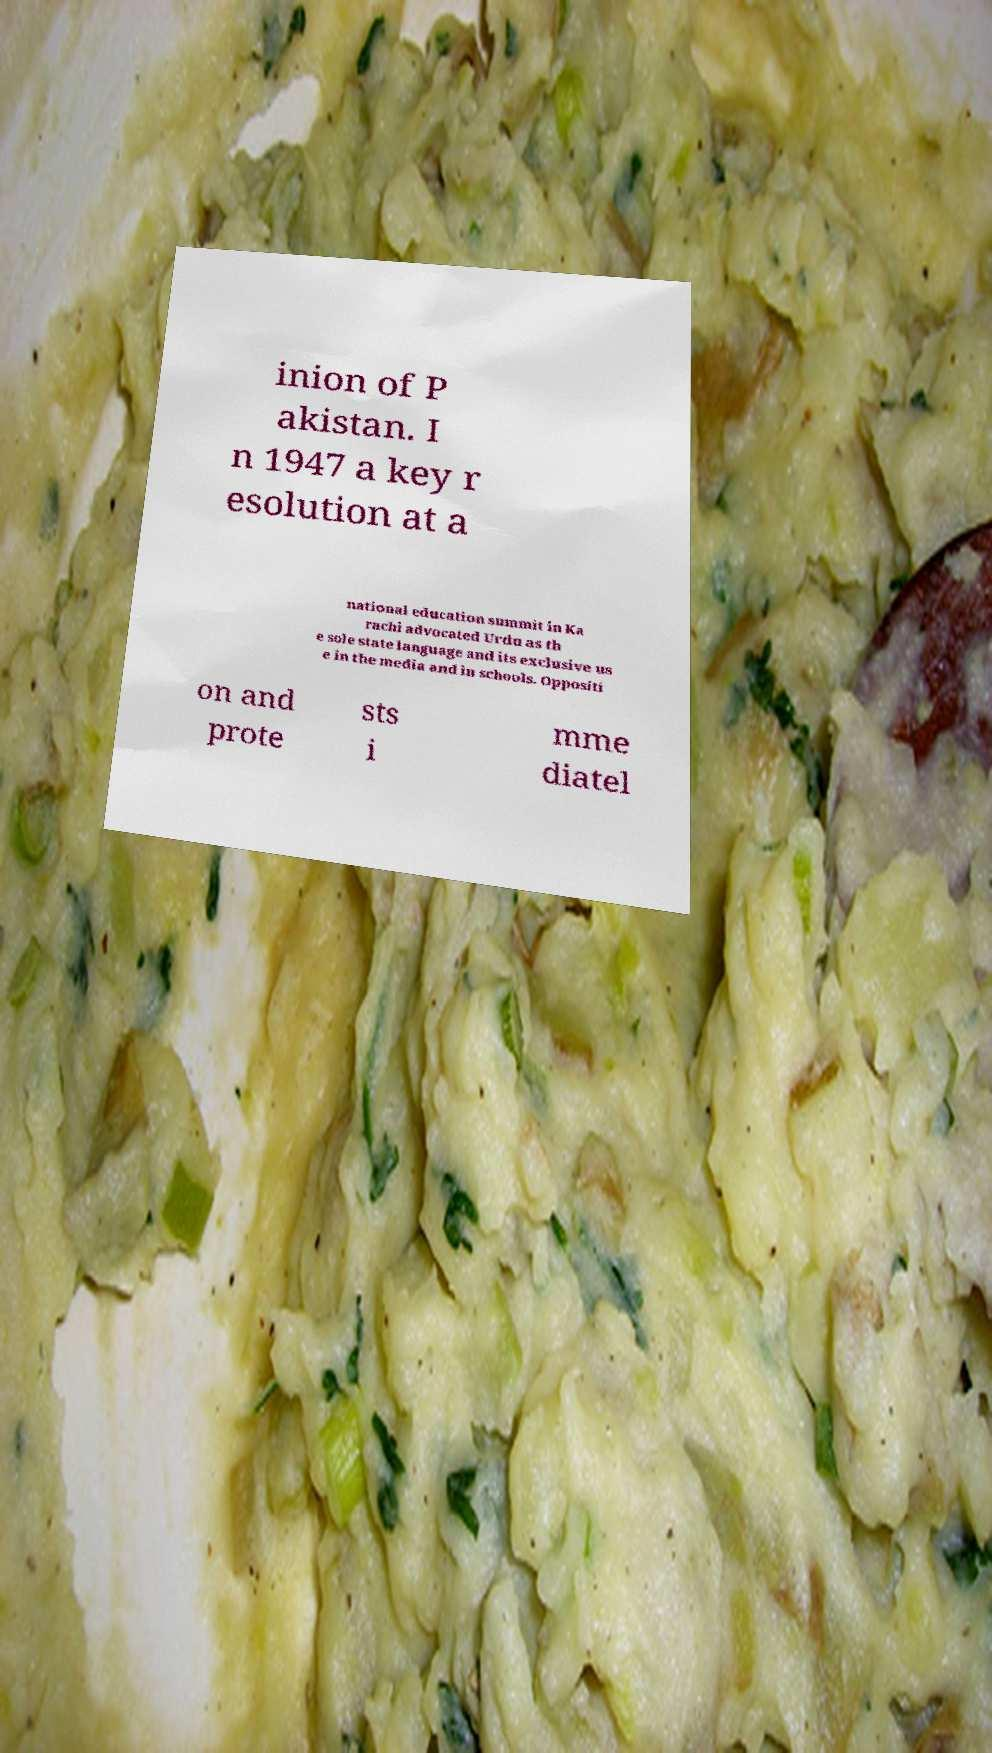There's text embedded in this image that I need extracted. Can you transcribe it verbatim? inion of P akistan. I n 1947 a key r esolution at a national education summit in Ka rachi advocated Urdu as th e sole state language and its exclusive us e in the media and in schools. Oppositi on and prote sts i mme diatel 